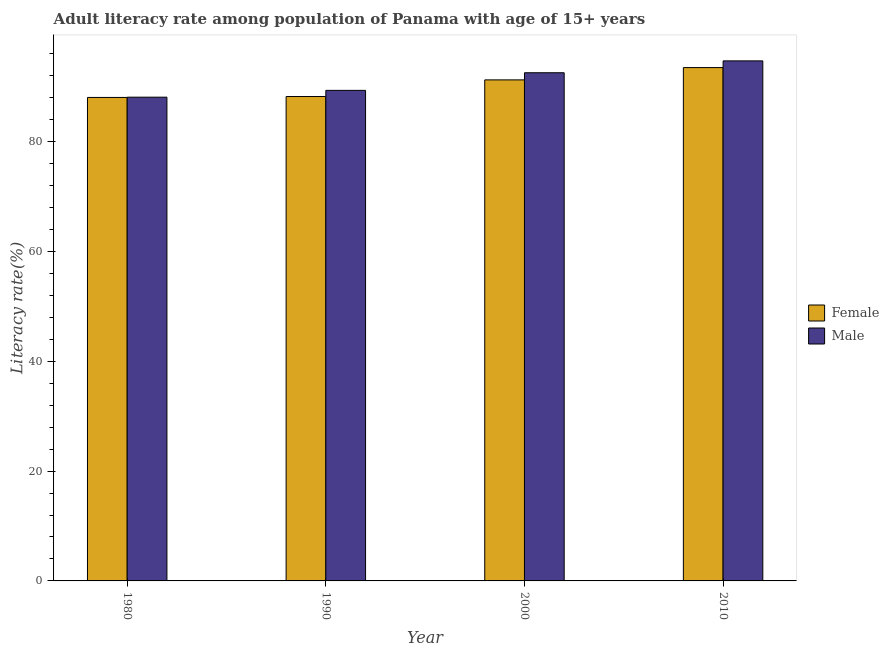How many different coloured bars are there?
Your answer should be compact. 2. How many groups of bars are there?
Your response must be concise. 4. Are the number of bars per tick equal to the number of legend labels?
Your answer should be very brief. Yes. Are the number of bars on each tick of the X-axis equal?
Your answer should be compact. Yes. How many bars are there on the 2nd tick from the left?
Make the answer very short. 2. In how many cases, is the number of bars for a given year not equal to the number of legend labels?
Ensure brevity in your answer.  0. What is the male adult literacy rate in 1980?
Make the answer very short. 88.1. Across all years, what is the maximum female adult literacy rate?
Your answer should be compact. 93.49. Across all years, what is the minimum female adult literacy rate?
Your answer should be compact. 88.05. In which year was the male adult literacy rate minimum?
Ensure brevity in your answer.  1980. What is the total male adult literacy rate in the graph?
Offer a very short reply. 364.69. What is the difference between the female adult literacy rate in 1990 and that in 2000?
Give a very brief answer. -3.03. What is the difference between the male adult literacy rate in 1980 and the female adult literacy rate in 2000?
Provide a succinct answer. -4.45. What is the average male adult literacy rate per year?
Offer a terse response. 91.17. In the year 1980, what is the difference between the female adult literacy rate and male adult literacy rate?
Make the answer very short. 0. In how many years, is the female adult literacy rate greater than 48 %?
Give a very brief answer. 4. What is the ratio of the male adult literacy rate in 1980 to that in 2000?
Keep it short and to the point. 0.95. What is the difference between the highest and the second highest female adult literacy rate?
Your response must be concise. 2.24. What is the difference between the highest and the lowest male adult literacy rate?
Ensure brevity in your answer.  6.61. In how many years, is the male adult literacy rate greater than the average male adult literacy rate taken over all years?
Ensure brevity in your answer.  2. Is the sum of the male adult literacy rate in 1980 and 2010 greater than the maximum female adult literacy rate across all years?
Give a very brief answer. Yes. What does the 2nd bar from the left in 1990 represents?
Your answer should be very brief. Male. Are all the bars in the graph horizontal?
Keep it short and to the point. No. What is the difference between two consecutive major ticks on the Y-axis?
Keep it short and to the point. 20. Are the values on the major ticks of Y-axis written in scientific E-notation?
Keep it short and to the point. No. Does the graph contain any zero values?
Make the answer very short. No. Where does the legend appear in the graph?
Keep it short and to the point. Center right. How many legend labels are there?
Your answer should be very brief. 2. What is the title of the graph?
Offer a very short reply. Adult literacy rate among population of Panama with age of 15+ years. What is the label or title of the X-axis?
Keep it short and to the point. Year. What is the label or title of the Y-axis?
Provide a succinct answer. Literacy rate(%). What is the Literacy rate(%) in Female in 1980?
Make the answer very short. 88.05. What is the Literacy rate(%) in Male in 1980?
Your response must be concise. 88.1. What is the Literacy rate(%) of Female in 1990?
Provide a short and direct response. 88.21. What is the Literacy rate(%) of Male in 1990?
Your response must be concise. 89.34. What is the Literacy rate(%) of Female in 2000?
Offer a terse response. 91.25. What is the Literacy rate(%) in Male in 2000?
Give a very brief answer. 92.55. What is the Literacy rate(%) in Female in 2010?
Your answer should be very brief. 93.49. What is the Literacy rate(%) in Male in 2010?
Your response must be concise. 94.71. Across all years, what is the maximum Literacy rate(%) of Female?
Make the answer very short. 93.49. Across all years, what is the maximum Literacy rate(%) of Male?
Offer a very short reply. 94.71. Across all years, what is the minimum Literacy rate(%) in Female?
Keep it short and to the point. 88.05. Across all years, what is the minimum Literacy rate(%) in Male?
Provide a succinct answer. 88.1. What is the total Literacy rate(%) in Female in the graph?
Provide a succinct answer. 360.99. What is the total Literacy rate(%) of Male in the graph?
Keep it short and to the point. 364.69. What is the difference between the Literacy rate(%) in Female in 1980 and that in 1990?
Provide a succinct answer. -0.17. What is the difference between the Literacy rate(%) in Male in 1980 and that in 1990?
Make the answer very short. -1.24. What is the difference between the Literacy rate(%) in Female in 1980 and that in 2000?
Offer a terse response. -3.2. What is the difference between the Literacy rate(%) in Male in 1980 and that in 2000?
Ensure brevity in your answer.  -4.45. What is the difference between the Literacy rate(%) of Female in 1980 and that in 2010?
Offer a terse response. -5.44. What is the difference between the Literacy rate(%) of Male in 1980 and that in 2010?
Provide a short and direct response. -6.61. What is the difference between the Literacy rate(%) in Female in 1990 and that in 2000?
Your answer should be compact. -3.03. What is the difference between the Literacy rate(%) in Male in 1990 and that in 2000?
Ensure brevity in your answer.  -3.21. What is the difference between the Literacy rate(%) in Female in 1990 and that in 2010?
Give a very brief answer. -5.27. What is the difference between the Literacy rate(%) in Male in 1990 and that in 2010?
Ensure brevity in your answer.  -5.37. What is the difference between the Literacy rate(%) of Female in 2000 and that in 2010?
Ensure brevity in your answer.  -2.24. What is the difference between the Literacy rate(%) in Male in 2000 and that in 2010?
Provide a short and direct response. -2.16. What is the difference between the Literacy rate(%) of Female in 1980 and the Literacy rate(%) of Male in 1990?
Keep it short and to the point. -1.29. What is the difference between the Literacy rate(%) in Female in 1980 and the Literacy rate(%) in Male in 2000?
Provide a succinct answer. -4.5. What is the difference between the Literacy rate(%) in Female in 1980 and the Literacy rate(%) in Male in 2010?
Make the answer very short. -6.66. What is the difference between the Literacy rate(%) in Female in 1990 and the Literacy rate(%) in Male in 2000?
Your response must be concise. -4.33. What is the difference between the Literacy rate(%) of Female in 1990 and the Literacy rate(%) of Male in 2010?
Your answer should be compact. -6.49. What is the difference between the Literacy rate(%) of Female in 2000 and the Literacy rate(%) of Male in 2010?
Offer a very short reply. -3.46. What is the average Literacy rate(%) of Female per year?
Your response must be concise. 90.25. What is the average Literacy rate(%) in Male per year?
Make the answer very short. 91.17. In the year 1980, what is the difference between the Literacy rate(%) of Female and Literacy rate(%) of Male?
Provide a short and direct response. -0.05. In the year 1990, what is the difference between the Literacy rate(%) in Female and Literacy rate(%) in Male?
Ensure brevity in your answer.  -1.12. In the year 2000, what is the difference between the Literacy rate(%) of Female and Literacy rate(%) of Male?
Provide a short and direct response. -1.3. In the year 2010, what is the difference between the Literacy rate(%) of Female and Literacy rate(%) of Male?
Your answer should be compact. -1.22. What is the ratio of the Literacy rate(%) in Male in 1980 to that in 1990?
Your answer should be very brief. 0.99. What is the ratio of the Literacy rate(%) in Female in 1980 to that in 2000?
Keep it short and to the point. 0.96. What is the ratio of the Literacy rate(%) of Male in 1980 to that in 2000?
Make the answer very short. 0.95. What is the ratio of the Literacy rate(%) of Female in 1980 to that in 2010?
Your response must be concise. 0.94. What is the ratio of the Literacy rate(%) of Male in 1980 to that in 2010?
Offer a very short reply. 0.93. What is the ratio of the Literacy rate(%) of Female in 1990 to that in 2000?
Provide a short and direct response. 0.97. What is the ratio of the Literacy rate(%) of Male in 1990 to that in 2000?
Offer a terse response. 0.97. What is the ratio of the Literacy rate(%) of Female in 1990 to that in 2010?
Your response must be concise. 0.94. What is the ratio of the Literacy rate(%) in Male in 1990 to that in 2010?
Provide a succinct answer. 0.94. What is the ratio of the Literacy rate(%) in Female in 2000 to that in 2010?
Your response must be concise. 0.98. What is the ratio of the Literacy rate(%) in Male in 2000 to that in 2010?
Provide a short and direct response. 0.98. What is the difference between the highest and the second highest Literacy rate(%) of Female?
Provide a short and direct response. 2.24. What is the difference between the highest and the second highest Literacy rate(%) of Male?
Provide a succinct answer. 2.16. What is the difference between the highest and the lowest Literacy rate(%) of Female?
Provide a short and direct response. 5.44. What is the difference between the highest and the lowest Literacy rate(%) of Male?
Give a very brief answer. 6.61. 